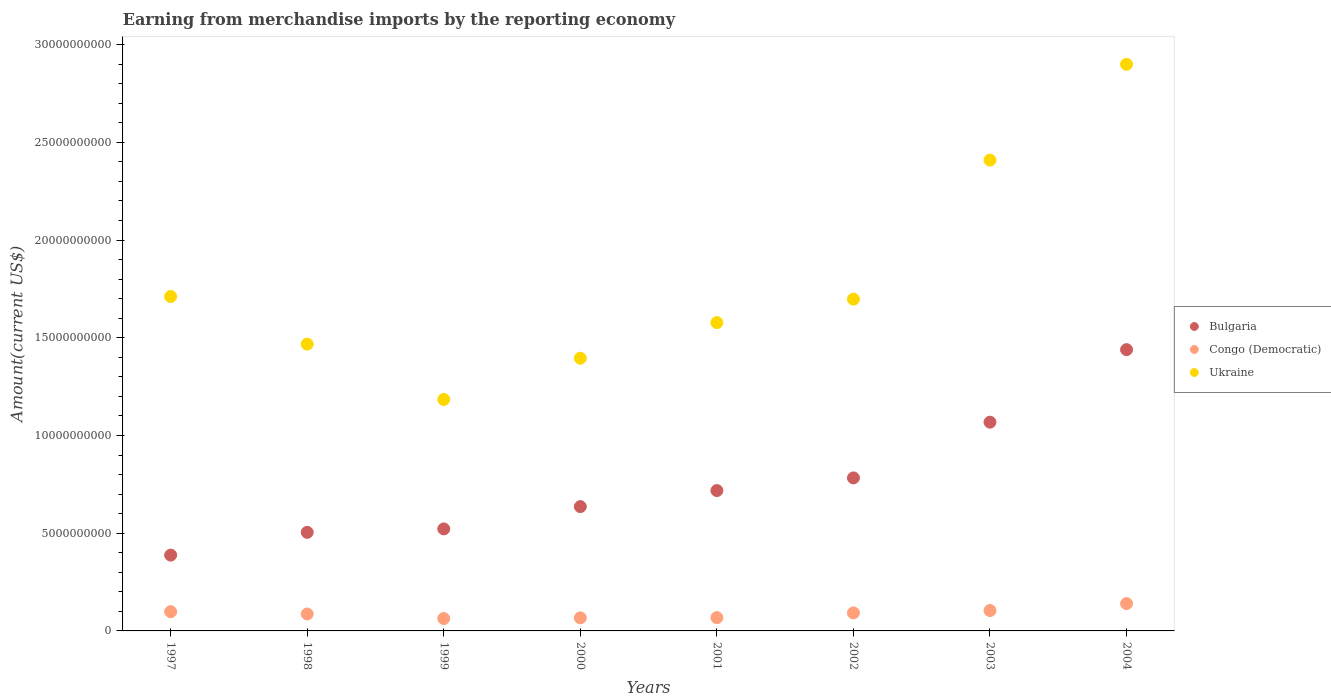Is the number of dotlines equal to the number of legend labels?
Your answer should be compact. Yes. What is the amount earned from merchandise imports in Bulgaria in 2003?
Offer a very short reply. 1.07e+1. Across all years, what is the maximum amount earned from merchandise imports in Bulgaria?
Ensure brevity in your answer.  1.44e+1. Across all years, what is the minimum amount earned from merchandise imports in Bulgaria?
Give a very brief answer. 3.88e+09. In which year was the amount earned from merchandise imports in Congo (Democratic) maximum?
Provide a short and direct response. 2004. In which year was the amount earned from merchandise imports in Bulgaria minimum?
Offer a terse response. 1997. What is the total amount earned from merchandise imports in Ukraine in the graph?
Provide a succinct answer. 1.43e+11. What is the difference between the amount earned from merchandise imports in Ukraine in 2002 and that in 2003?
Provide a short and direct response. -7.11e+09. What is the difference between the amount earned from merchandise imports in Ukraine in 1997 and the amount earned from merchandise imports in Congo (Democratic) in 2001?
Your response must be concise. 1.64e+1. What is the average amount earned from merchandise imports in Ukraine per year?
Your answer should be very brief. 1.79e+1. In the year 1997, what is the difference between the amount earned from merchandise imports in Bulgaria and amount earned from merchandise imports in Ukraine?
Your answer should be compact. -1.32e+1. In how many years, is the amount earned from merchandise imports in Congo (Democratic) greater than 7000000000 US$?
Provide a succinct answer. 0. What is the ratio of the amount earned from merchandise imports in Congo (Democratic) in 1998 to that in 1999?
Make the answer very short. 1.37. Is the difference between the amount earned from merchandise imports in Bulgaria in 2003 and 2004 greater than the difference between the amount earned from merchandise imports in Ukraine in 2003 and 2004?
Your answer should be very brief. Yes. What is the difference between the highest and the second highest amount earned from merchandise imports in Bulgaria?
Keep it short and to the point. 3.71e+09. What is the difference between the highest and the lowest amount earned from merchandise imports in Bulgaria?
Offer a very short reply. 1.05e+1. In how many years, is the amount earned from merchandise imports in Bulgaria greater than the average amount earned from merchandise imports in Bulgaria taken over all years?
Your response must be concise. 3. How many dotlines are there?
Keep it short and to the point. 3. How many years are there in the graph?
Give a very brief answer. 8. Are the values on the major ticks of Y-axis written in scientific E-notation?
Your response must be concise. No. Does the graph contain any zero values?
Keep it short and to the point. No. What is the title of the graph?
Your response must be concise. Earning from merchandise imports by the reporting economy. Does "Latin America(all income levels)" appear as one of the legend labels in the graph?
Provide a succinct answer. No. What is the label or title of the X-axis?
Your answer should be very brief. Years. What is the label or title of the Y-axis?
Your answer should be very brief. Amount(current US$). What is the Amount(current US$) in Bulgaria in 1997?
Provide a short and direct response. 3.88e+09. What is the Amount(current US$) in Congo (Democratic) in 1997?
Keep it short and to the point. 9.85e+08. What is the Amount(current US$) in Ukraine in 1997?
Your answer should be very brief. 1.71e+1. What is the Amount(current US$) of Bulgaria in 1998?
Make the answer very short. 5.04e+09. What is the Amount(current US$) in Congo (Democratic) in 1998?
Your answer should be compact. 8.67e+08. What is the Amount(current US$) of Ukraine in 1998?
Make the answer very short. 1.47e+1. What is the Amount(current US$) of Bulgaria in 1999?
Keep it short and to the point. 5.22e+09. What is the Amount(current US$) in Congo (Democratic) in 1999?
Your answer should be very brief. 6.35e+08. What is the Amount(current US$) of Ukraine in 1999?
Provide a short and direct response. 1.18e+1. What is the Amount(current US$) in Bulgaria in 2000?
Offer a very short reply. 6.36e+09. What is the Amount(current US$) in Congo (Democratic) in 2000?
Your response must be concise. 6.68e+08. What is the Amount(current US$) of Ukraine in 2000?
Your answer should be very brief. 1.40e+1. What is the Amount(current US$) of Bulgaria in 2001?
Offer a very short reply. 7.18e+09. What is the Amount(current US$) in Congo (Democratic) in 2001?
Ensure brevity in your answer.  6.80e+08. What is the Amount(current US$) in Ukraine in 2001?
Provide a short and direct response. 1.58e+1. What is the Amount(current US$) of Bulgaria in 2002?
Your response must be concise. 7.83e+09. What is the Amount(current US$) in Congo (Democratic) in 2002?
Your answer should be very brief. 9.22e+08. What is the Amount(current US$) in Ukraine in 2002?
Your response must be concise. 1.70e+1. What is the Amount(current US$) in Bulgaria in 2003?
Keep it short and to the point. 1.07e+1. What is the Amount(current US$) of Congo (Democratic) in 2003?
Your answer should be compact. 1.05e+09. What is the Amount(current US$) of Ukraine in 2003?
Ensure brevity in your answer.  2.41e+1. What is the Amount(current US$) in Bulgaria in 2004?
Offer a terse response. 1.44e+1. What is the Amount(current US$) in Congo (Democratic) in 2004?
Provide a short and direct response. 1.40e+09. What is the Amount(current US$) in Ukraine in 2004?
Give a very brief answer. 2.90e+1. Across all years, what is the maximum Amount(current US$) in Bulgaria?
Your answer should be compact. 1.44e+1. Across all years, what is the maximum Amount(current US$) in Congo (Democratic)?
Offer a terse response. 1.40e+09. Across all years, what is the maximum Amount(current US$) of Ukraine?
Offer a terse response. 2.90e+1. Across all years, what is the minimum Amount(current US$) in Bulgaria?
Ensure brevity in your answer.  3.88e+09. Across all years, what is the minimum Amount(current US$) in Congo (Democratic)?
Your answer should be very brief. 6.35e+08. Across all years, what is the minimum Amount(current US$) in Ukraine?
Ensure brevity in your answer.  1.18e+1. What is the total Amount(current US$) in Bulgaria in the graph?
Make the answer very short. 6.06e+1. What is the total Amount(current US$) in Congo (Democratic) in the graph?
Make the answer very short. 7.20e+09. What is the total Amount(current US$) of Ukraine in the graph?
Provide a short and direct response. 1.43e+11. What is the difference between the Amount(current US$) in Bulgaria in 1997 and that in 1998?
Keep it short and to the point. -1.16e+09. What is the difference between the Amount(current US$) of Congo (Democratic) in 1997 and that in 1998?
Your response must be concise. 1.18e+08. What is the difference between the Amount(current US$) in Ukraine in 1997 and that in 1998?
Provide a short and direct response. 2.44e+09. What is the difference between the Amount(current US$) of Bulgaria in 1997 and that in 1999?
Provide a succinct answer. -1.34e+09. What is the difference between the Amount(current US$) in Congo (Democratic) in 1997 and that in 1999?
Ensure brevity in your answer.  3.50e+08. What is the difference between the Amount(current US$) of Ukraine in 1997 and that in 1999?
Offer a terse response. 5.27e+09. What is the difference between the Amount(current US$) of Bulgaria in 1997 and that in 2000?
Offer a very short reply. -2.48e+09. What is the difference between the Amount(current US$) of Congo (Democratic) in 1997 and that in 2000?
Keep it short and to the point. 3.17e+08. What is the difference between the Amount(current US$) in Ukraine in 1997 and that in 2000?
Offer a very short reply. 3.16e+09. What is the difference between the Amount(current US$) of Bulgaria in 1997 and that in 2001?
Your response must be concise. -3.30e+09. What is the difference between the Amount(current US$) of Congo (Democratic) in 1997 and that in 2001?
Make the answer very short. 3.05e+08. What is the difference between the Amount(current US$) in Ukraine in 1997 and that in 2001?
Your answer should be very brief. 1.34e+09. What is the difference between the Amount(current US$) of Bulgaria in 1997 and that in 2002?
Offer a terse response. -3.95e+09. What is the difference between the Amount(current US$) of Congo (Democratic) in 1997 and that in 2002?
Your response must be concise. 6.32e+07. What is the difference between the Amount(current US$) in Ukraine in 1997 and that in 2002?
Your answer should be compact. 1.37e+08. What is the difference between the Amount(current US$) in Bulgaria in 1997 and that in 2003?
Give a very brief answer. -6.80e+09. What is the difference between the Amount(current US$) in Congo (Democratic) in 1997 and that in 2003?
Ensure brevity in your answer.  -6.04e+07. What is the difference between the Amount(current US$) of Ukraine in 1997 and that in 2003?
Your response must be concise. -6.98e+09. What is the difference between the Amount(current US$) of Bulgaria in 1997 and that in 2004?
Your answer should be compact. -1.05e+1. What is the difference between the Amount(current US$) of Congo (Democratic) in 1997 and that in 2004?
Give a very brief answer. -4.14e+08. What is the difference between the Amount(current US$) of Ukraine in 1997 and that in 2004?
Ensure brevity in your answer.  -1.19e+1. What is the difference between the Amount(current US$) in Bulgaria in 1998 and that in 1999?
Provide a succinct answer. -1.76e+08. What is the difference between the Amount(current US$) of Congo (Democratic) in 1998 and that in 1999?
Provide a succinct answer. 2.32e+08. What is the difference between the Amount(current US$) in Ukraine in 1998 and that in 1999?
Your answer should be very brief. 2.83e+09. What is the difference between the Amount(current US$) of Bulgaria in 1998 and that in 2000?
Your response must be concise. -1.32e+09. What is the difference between the Amount(current US$) of Congo (Democratic) in 1998 and that in 2000?
Ensure brevity in your answer.  1.98e+08. What is the difference between the Amount(current US$) of Ukraine in 1998 and that in 2000?
Keep it short and to the point. 7.21e+08. What is the difference between the Amount(current US$) of Bulgaria in 1998 and that in 2001?
Your response must be concise. -2.14e+09. What is the difference between the Amount(current US$) in Congo (Democratic) in 1998 and that in 2001?
Your answer should be compact. 1.86e+08. What is the difference between the Amount(current US$) in Ukraine in 1998 and that in 2001?
Your answer should be compact. -1.10e+09. What is the difference between the Amount(current US$) in Bulgaria in 1998 and that in 2002?
Keep it short and to the point. -2.79e+09. What is the difference between the Amount(current US$) of Congo (Democratic) in 1998 and that in 2002?
Your response must be concise. -5.51e+07. What is the difference between the Amount(current US$) of Ukraine in 1998 and that in 2002?
Provide a short and direct response. -2.30e+09. What is the difference between the Amount(current US$) of Bulgaria in 1998 and that in 2003?
Give a very brief answer. -5.64e+09. What is the difference between the Amount(current US$) of Congo (Democratic) in 1998 and that in 2003?
Keep it short and to the point. -1.79e+08. What is the difference between the Amount(current US$) of Ukraine in 1998 and that in 2003?
Your response must be concise. -9.42e+09. What is the difference between the Amount(current US$) in Bulgaria in 1998 and that in 2004?
Give a very brief answer. -9.35e+09. What is the difference between the Amount(current US$) of Congo (Democratic) in 1998 and that in 2004?
Your answer should be very brief. -5.33e+08. What is the difference between the Amount(current US$) of Ukraine in 1998 and that in 2004?
Your answer should be very brief. -1.43e+1. What is the difference between the Amount(current US$) in Bulgaria in 1999 and that in 2000?
Your answer should be very brief. -1.14e+09. What is the difference between the Amount(current US$) of Congo (Democratic) in 1999 and that in 2000?
Offer a very short reply. -3.35e+07. What is the difference between the Amount(current US$) of Ukraine in 1999 and that in 2000?
Ensure brevity in your answer.  -2.11e+09. What is the difference between the Amount(current US$) in Bulgaria in 1999 and that in 2001?
Keep it short and to the point. -1.96e+09. What is the difference between the Amount(current US$) of Congo (Democratic) in 1999 and that in 2001?
Offer a very short reply. -4.54e+07. What is the difference between the Amount(current US$) in Ukraine in 1999 and that in 2001?
Offer a terse response. -3.93e+09. What is the difference between the Amount(current US$) in Bulgaria in 1999 and that in 2002?
Your answer should be very brief. -2.61e+09. What is the difference between the Amount(current US$) of Congo (Democratic) in 1999 and that in 2002?
Offer a very short reply. -2.87e+08. What is the difference between the Amount(current US$) in Ukraine in 1999 and that in 2002?
Offer a terse response. -5.13e+09. What is the difference between the Amount(current US$) in Bulgaria in 1999 and that in 2003?
Your answer should be very brief. -5.46e+09. What is the difference between the Amount(current US$) of Congo (Democratic) in 1999 and that in 2003?
Ensure brevity in your answer.  -4.11e+08. What is the difference between the Amount(current US$) of Ukraine in 1999 and that in 2003?
Keep it short and to the point. -1.22e+1. What is the difference between the Amount(current US$) of Bulgaria in 1999 and that in 2004?
Give a very brief answer. -9.17e+09. What is the difference between the Amount(current US$) in Congo (Democratic) in 1999 and that in 2004?
Your response must be concise. -7.65e+08. What is the difference between the Amount(current US$) in Ukraine in 1999 and that in 2004?
Offer a terse response. -1.72e+1. What is the difference between the Amount(current US$) in Bulgaria in 2000 and that in 2001?
Your answer should be compact. -8.21e+08. What is the difference between the Amount(current US$) in Congo (Democratic) in 2000 and that in 2001?
Provide a succinct answer. -1.19e+07. What is the difference between the Amount(current US$) in Ukraine in 2000 and that in 2001?
Make the answer very short. -1.82e+09. What is the difference between the Amount(current US$) of Bulgaria in 2000 and that in 2002?
Provide a short and direct response. -1.47e+09. What is the difference between the Amount(current US$) in Congo (Democratic) in 2000 and that in 2002?
Offer a terse response. -2.53e+08. What is the difference between the Amount(current US$) in Ukraine in 2000 and that in 2002?
Your answer should be very brief. -3.02e+09. What is the difference between the Amount(current US$) in Bulgaria in 2000 and that in 2003?
Keep it short and to the point. -4.32e+09. What is the difference between the Amount(current US$) of Congo (Democratic) in 2000 and that in 2003?
Make the answer very short. -3.77e+08. What is the difference between the Amount(current US$) of Ukraine in 2000 and that in 2003?
Your answer should be compact. -1.01e+1. What is the difference between the Amount(current US$) in Bulgaria in 2000 and that in 2004?
Offer a very short reply. -8.03e+09. What is the difference between the Amount(current US$) of Congo (Democratic) in 2000 and that in 2004?
Give a very brief answer. -7.31e+08. What is the difference between the Amount(current US$) of Ukraine in 2000 and that in 2004?
Your answer should be compact. -1.50e+1. What is the difference between the Amount(current US$) of Bulgaria in 2001 and that in 2002?
Offer a terse response. -6.48e+08. What is the difference between the Amount(current US$) of Congo (Democratic) in 2001 and that in 2002?
Keep it short and to the point. -2.42e+08. What is the difference between the Amount(current US$) of Ukraine in 2001 and that in 2002?
Give a very brief answer. -1.20e+09. What is the difference between the Amount(current US$) of Bulgaria in 2001 and that in 2003?
Offer a very short reply. -3.50e+09. What is the difference between the Amount(current US$) in Congo (Democratic) in 2001 and that in 2003?
Give a very brief answer. -3.65e+08. What is the difference between the Amount(current US$) in Ukraine in 2001 and that in 2003?
Your answer should be very brief. -8.31e+09. What is the difference between the Amount(current US$) in Bulgaria in 2001 and that in 2004?
Your response must be concise. -7.21e+09. What is the difference between the Amount(current US$) in Congo (Democratic) in 2001 and that in 2004?
Offer a terse response. -7.19e+08. What is the difference between the Amount(current US$) of Ukraine in 2001 and that in 2004?
Your answer should be very brief. -1.32e+1. What is the difference between the Amount(current US$) of Bulgaria in 2002 and that in 2003?
Offer a very short reply. -2.85e+09. What is the difference between the Amount(current US$) of Congo (Democratic) in 2002 and that in 2003?
Your answer should be compact. -1.24e+08. What is the difference between the Amount(current US$) in Ukraine in 2002 and that in 2003?
Provide a succinct answer. -7.11e+09. What is the difference between the Amount(current US$) in Bulgaria in 2002 and that in 2004?
Make the answer very short. -6.56e+09. What is the difference between the Amount(current US$) of Congo (Democratic) in 2002 and that in 2004?
Make the answer very short. -4.78e+08. What is the difference between the Amount(current US$) of Ukraine in 2002 and that in 2004?
Give a very brief answer. -1.20e+1. What is the difference between the Amount(current US$) in Bulgaria in 2003 and that in 2004?
Offer a very short reply. -3.71e+09. What is the difference between the Amount(current US$) of Congo (Democratic) in 2003 and that in 2004?
Provide a succinct answer. -3.54e+08. What is the difference between the Amount(current US$) of Ukraine in 2003 and that in 2004?
Give a very brief answer. -4.90e+09. What is the difference between the Amount(current US$) in Bulgaria in 1997 and the Amount(current US$) in Congo (Democratic) in 1998?
Your answer should be compact. 3.01e+09. What is the difference between the Amount(current US$) in Bulgaria in 1997 and the Amount(current US$) in Ukraine in 1998?
Provide a short and direct response. -1.08e+1. What is the difference between the Amount(current US$) of Congo (Democratic) in 1997 and the Amount(current US$) of Ukraine in 1998?
Offer a very short reply. -1.37e+1. What is the difference between the Amount(current US$) of Bulgaria in 1997 and the Amount(current US$) of Congo (Democratic) in 1999?
Provide a succinct answer. 3.24e+09. What is the difference between the Amount(current US$) in Bulgaria in 1997 and the Amount(current US$) in Ukraine in 1999?
Give a very brief answer. -7.96e+09. What is the difference between the Amount(current US$) of Congo (Democratic) in 1997 and the Amount(current US$) of Ukraine in 1999?
Provide a succinct answer. -1.09e+1. What is the difference between the Amount(current US$) in Bulgaria in 1997 and the Amount(current US$) in Congo (Democratic) in 2000?
Ensure brevity in your answer.  3.21e+09. What is the difference between the Amount(current US$) in Bulgaria in 1997 and the Amount(current US$) in Ukraine in 2000?
Ensure brevity in your answer.  -1.01e+1. What is the difference between the Amount(current US$) of Congo (Democratic) in 1997 and the Amount(current US$) of Ukraine in 2000?
Keep it short and to the point. -1.30e+1. What is the difference between the Amount(current US$) in Bulgaria in 1997 and the Amount(current US$) in Congo (Democratic) in 2001?
Your answer should be compact. 3.20e+09. What is the difference between the Amount(current US$) in Bulgaria in 1997 and the Amount(current US$) in Ukraine in 2001?
Ensure brevity in your answer.  -1.19e+1. What is the difference between the Amount(current US$) in Congo (Democratic) in 1997 and the Amount(current US$) in Ukraine in 2001?
Offer a very short reply. -1.48e+1. What is the difference between the Amount(current US$) of Bulgaria in 1997 and the Amount(current US$) of Congo (Democratic) in 2002?
Give a very brief answer. 2.96e+09. What is the difference between the Amount(current US$) in Bulgaria in 1997 and the Amount(current US$) in Ukraine in 2002?
Give a very brief answer. -1.31e+1. What is the difference between the Amount(current US$) in Congo (Democratic) in 1997 and the Amount(current US$) in Ukraine in 2002?
Ensure brevity in your answer.  -1.60e+1. What is the difference between the Amount(current US$) in Bulgaria in 1997 and the Amount(current US$) in Congo (Democratic) in 2003?
Provide a short and direct response. 2.83e+09. What is the difference between the Amount(current US$) of Bulgaria in 1997 and the Amount(current US$) of Ukraine in 2003?
Your answer should be compact. -2.02e+1. What is the difference between the Amount(current US$) in Congo (Democratic) in 1997 and the Amount(current US$) in Ukraine in 2003?
Your answer should be compact. -2.31e+1. What is the difference between the Amount(current US$) in Bulgaria in 1997 and the Amount(current US$) in Congo (Democratic) in 2004?
Provide a succinct answer. 2.48e+09. What is the difference between the Amount(current US$) of Bulgaria in 1997 and the Amount(current US$) of Ukraine in 2004?
Offer a very short reply. -2.51e+1. What is the difference between the Amount(current US$) of Congo (Democratic) in 1997 and the Amount(current US$) of Ukraine in 2004?
Give a very brief answer. -2.80e+1. What is the difference between the Amount(current US$) of Bulgaria in 1998 and the Amount(current US$) of Congo (Democratic) in 1999?
Give a very brief answer. 4.41e+09. What is the difference between the Amount(current US$) of Bulgaria in 1998 and the Amount(current US$) of Ukraine in 1999?
Provide a succinct answer. -6.80e+09. What is the difference between the Amount(current US$) of Congo (Democratic) in 1998 and the Amount(current US$) of Ukraine in 1999?
Your answer should be very brief. -1.10e+1. What is the difference between the Amount(current US$) of Bulgaria in 1998 and the Amount(current US$) of Congo (Democratic) in 2000?
Ensure brevity in your answer.  4.38e+09. What is the difference between the Amount(current US$) of Bulgaria in 1998 and the Amount(current US$) of Ukraine in 2000?
Keep it short and to the point. -8.91e+09. What is the difference between the Amount(current US$) in Congo (Democratic) in 1998 and the Amount(current US$) in Ukraine in 2000?
Give a very brief answer. -1.31e+1. What is the difference between the Amount(current US$) of Bulgaria in 1998 and the Amount(current US$) of Congo (Democratic) in 2001?
Keep it short and to the point. 4.36e+09. What is the difference between the Amount(current US$) of Bulgaria in 1998 and the Amount(current US$) of Ukraine in 2001?
Your answer should be compact. -1.07e+1. What is the difference between the Amount(current US$) in Congo (Democratic) in 1998 and the Amount(current US$) in Ukraine in 2001?
Provide a succinct answer. -1.49e+1. What is the difference between the Amount(current US$) in Bulgaria in 1998 and the Amount(current US$) in Congo (Democratic) in 2002?
Keep it short and to the point. 4.12e+09. What is the difference between the Amount(current US$) in Bulgaria in 1998 and the Amount(current US$) in Ukraine in 2002?
Keep it short and to the point. -1.19e+1. What is the difference between the Amount(current US$) of Congo (Democratic) in 1998 and the Amount(current US$) of Ukraine in 2002?
Offer a very short reply. -1.61e+1. What is the difference between the Amount(current US$) in Bulgaria in 1998 and the Amount(current US$) in Congo (Democratic) in 2003?
Your response must be concise. 4.00e+09. What is the difference between the Amount(current US$) of Bulgaria in 1998 and the Amount(current US$) of Ukraine in 2003?
Offer a very short reply. -1.90e+1. What is the difference between the Amount(current US$) in Congo (Democratic) in 1998 and the Amount(current US$) in Ukraine in 2003?
Keep it short and to the point. -2.32e+1. What is the difference between the Amount(current US$) of Bulgaria in 1998 and the Amount(current US$) of Congo (Democratic) in 2004?
Your answer should be compact. 3.65e+09. What is the difference between the Amount(current US$) of Bulgaria in 1998 and the Amount(current US$) of Ukraine in 2004?
Offer a very short reply. -2.40e+1. What is the difference between the Amount(current US$) of Congo (Democratic) in 1998 and the Amount(current US$) of Ukraine in 2004?
Your answer should be compact. -2.81e+1. What is the difference between the Amount(current US$) in Bulgaria in 1999 and the Amount(current US$) in Congo (Democratic) in 2000?
Provide a succinct answer. 4.55e+09. What is the difference between the Amount(current US$) in Bulgaria in 1999 and the Amount(current US$) in Ukraine in 2000?
Your response must be concise. -8.73e+09. What is the difference between the Amount(current US$) of Congo (Democratic) in 1999 and the Amount(current US$) of Ukraine in 2000?
Give a very brief answer. -1.33e+1. What is the difference between the Amount(current US$) in Bulgaria in 1999 and the Amount(current US$) in Congo (Democratic) in 2001?
Offer a very short reply. 4.54e+09. What is the difference between the Amount(current US$) of Bulgaria in 1999 and the Amount(current US$) of Ukraine in 2001?
Your response must be concise. -1.06e+1. What is the difference between the Amount(current US$) in Congo (Democratic) in 1999 and the Amount(current US$) in Ukraine in 2001?
Your answer should be very brief. -1.51e+1. What is the difference between the Amount(current US$) of Bulgaria in 1999 and the Amount(current US$) of Congo (Democratic) in 2002?
Provide a succinct answer. 4.30e+09. What is the difference between the Amount(current US$) of Bulgaria in 1999 and the Amount(current US$) of Ukraine in 2002?
Give a very brief answer. -1.18e+1. What is the difference between the Amount(current US$) in Congo (Democratic) in 1999 and the Amount(current US$) in Ukraine in 2002?
Provide a succinct answer. -1.63e+1. What is the difference between the Amount(current US$) of Bulgaria in 1999 and the Amount(current US$) of Congo (Democratic) in 2003?
Offer a terse response. 4.17e+09. What is the difference between the Amount(current US$) in Bulgaria in 1999 and the Amount(current US$) in Ukraine in 2003?
Provide a succinct answer. -1.89e+1. What is the difference between the Amount(current US$) in Congo (Democratic) in 1999 and the Amount(current US$) in Ukraine in 2003?
Your response must be concise. -2.35e+1. What is the difference between the Amount(current US$) in Bulgaria in 1999 and the Amount(current US$) in Congo (Democratic) in 2004?
Your response must be concise. 3.82e+09. What is the difference between the Amount(current US$) in Bulgaria in 1999 and the Amount(current US$) in Ukraine in 2004?
Your response must be concise. -2.38e+1. What is the difference between the Amount(current US$) of Congo (Democratic) in 1999 and the Amount(current US$) of Ukraine in 2004?
Make the answer very short. -2.84e+1. What is the difference between the Amount(current US$) of Bulgaria in 2000 and the Amount(current US$) of Congo (Democratic) in 2001?
Offer a terse response. 5.68e+09. What is the difference between the Amount(current US$) in Bulgaria in 2000 and the Amount(current US$) in Ukraine in 2001?
Offer a terse response. -9.42e+09. What is the difference between the Amount(current US$) in Congo (Democratic) in 2000 and the Amount(current US$) in Ukraine in 2001?
Offer a terse response. -1.51e+1. What is the difference between the Amount(current US$) in Bulgaria in 2000 and the Amount(current US$) in Congo (Democratic) in 2002?
Your response must be concise. 5.44e+09. What is the difference between the Amount(current US$) in Bulgaria in 2000 and the Amount(current US$) in Ukraine in 2002?
Provide a succinct answer. -1.06e+1. What is the difference between the Amount(current US$) in Congo (Democratic) in 2000 and the Amount(current US$) in Ukraine in 2002?
Ensure brevity in your answer.  -1.63e+1. What is the difference between the Amount(current US$) in Bulgaria in 2000 and the Amount(current US$) in Congo (Democratic) in 2003?
Keep it short and to the point. 5.32e+09. What is the difference between the Amount(current US$) in Bulgaria in 2000 and the Amount(current US$) in Ukraine in 2003?
Offer a terse response. -1.77e+1. What is the difference between the Amount(current US$) in Congo (Democratic) in 2000 and the Amount(current US$) in Ukraine in 2003?
Provide a succinct answer. -2.34e+1. What is the difference between the Amount(current US$) in Bulgaria in 2000 and the Amount(current US$) in Congo (Democratic) in 2004?
Provide a short and direct response. 4.96e+09. What is the difference between the Amount(current US$) of Bulgaria in 2000 and the Amount(current US$) of Ukraine in 2004?
Your answer should be compact. -2.26e+1. What is the difference between the Amount(current US$) of Congo (Democratic) in 2000 and the Amount(current US$) of Ukraine in 2004?
Provide a succinct answer. -2.83e+1. What is the difference between the Amount(current US$) in Bulgaria in 2001 and the Amount(current US$) in Congo (Democratic) in 2002?
Your answer should be very brief. 6.26e+09. What is the difference between the Amount(current US$) of Bulgaria in 2001 and the Amount(current US$) of Ukraine in 2002?
Provide a short and direct response. -9.79e+09. What is the difference between the Amount(current US$) in Congo (Democratic) in 2001 and the Amount(current US$) in Ukraine in 2002?
Keep it short and to the point. -1.63e+1. What is the difference between the Amount(current US$) of Bulgaria in 2001 and the Amount(current US$) of Congo (Democratic) in 2003?
Provide a succinct answer. 6.14e+09. What is the difference between the Amount(current US$) of Bulgaria in 2001 and the Amount(current US$) of Ukraine in 2003?
Your answer should be compact. -1.69e+1. What is the difference between the Amount(current US$) in Congo (Democratic) in 2001 and the Amount(current US$) in Ukraine in 2003?
Your answer should be compact. -2.34e+1. What is the difference between the Amount(current US$) in Bulgaria in 2001 and the Amount(current US$) in Congo (Democratic) in 2004?
Offer a very short reply. 5.78e+09. What is the difference between the Amount(current US$) of Bulgaria in 2001 and the Amount(current US$) of Ukraine in 2004?
Make the answer very short. -2.18e+1. What is the difference between the Amount(current US$) of Congo (Democratic) in 2001 and the Amount(current US$) of Ukraine in 2004?
Provide a short and direct response. -2.83e+1. What is the difference between the Amount(current US$) in Bulgaria in 2002 and the Amount(current US$) in Congo (Democratic) in 2003?
Give a very brief answer. 6.79e+09. What is the difference between the Amount(current US$) in Bulgaria in 2002 and the Amount(current US$) in Ukraine in 2003?
Ensure brevity in your answer.  -1.63e+1. What is the difference between the Amount(current US$) of Congo (Democratic) in 2002 and the Amount(current US$) of Ukraine in 2003?
Your answer should be very brief. -2.32e+1. What is the difference between the Amount(current US$) in Bulgaria in 2002 and the Amount(current US$) in Congo (Democratic) in 2004?
Provide a succinct answer. 6.43e+09. What is the difference between the Amount(current US$) of Bulgaria in 2002 and the Amount(current US$) of Ukraine in 2004?
Keep it short and to the point. -2.12e+1. What is the difference between the Amount(current US$) of Congo (Democratic) in 2002 and the Amount(current US$) of Ukraine in 2004?
Offer a terse response. -2.81e+1. What is the difference between the Amount(current US$) in Bulgaria in 2003 and the Amount(current US$) in Congo (Democratic) in 2004?
Make the answer very short. 9.28e+09. What is the difference between the Amount(current US$) of Bulgaria in 2003 and the Amount(current US$) of Ukraine in 2004?
Your response must be concise. -1.83e+1. What is the difference between the Amount(current US$) of Congo (Democratic) in 2003 and the Amount(current US$) of Ukraine in 2004?
Your answer should be compact. -2.80e+1. What is the average Amount(current US$) in Bulgaria per year?
Your answer should be compact. 7.57e+09. What is the average Amount(current US$) in Congo (Democratic) per year?
Offer a very short reply. 9.00e+08. What is the average Amount(current US$) in Ukraine per year?
Your response must be concise. 1.79e+1. In the year 1997, what is the difference between the Amount(current US$) of Bulgaria and Amount(current US$) of Congo (Democratic)?
Keep it short and to the point. 2.89e+09. In the year 1997, what is the difference between the Amount(current US$) of Bulgaria and Amount(current US$) of Ukraine?
Your answer should be compact. -1.32e+1. In the year 1997, what is the difference between the Amount(current US$) of Congo (Democratic) and Amount(current US$) of Ukraine?
Ensure brevity in your answer.  -1.61e+1. In the year 1998, what is the difference between the Amount(current US$) of Bulgaria and Amount(current US$) of Congo (Democratic)?
Provide a succinct answer. 4.18e+09. In the year 1998, what is the difference between the Amount(current US$) of Bulgaria and Amount(current US$) of Ukraine?
Provide a short and direct response. -9.63e+09. In the year 1998, what is the difference between the Amount(current US$) in Congo (Democratic) and Amount(current US$) in Ukraine?
Ensure brevity in your answer.  -1.38e+1. In the year 1999, what is the difference between the Amount(current US$) of Bulgaria and Amount(current US$) of Congo (Democratic)?
Ensure brevity in your answer.  4.59e+09. In the year 1999, what is the difference between the Amount(current US$) in Bulgaria and Amount(current US$) in Ukraine?
Your answer should be very brief. -6.62e+09. In the year 1999, what is the difference between the Amount(current US$) in Congo (Democratic) and Amount(current US$) in Ukraine?
Provide a short and direct response. -1.12e+1. In the year 2000, what is the difference between the Amount(current US$) of Bulgaria and Amount(current US$) of Congo (Democratic)?
Ensure brevity in your answer.  5.69e+09. In the year 2000, what is the difference between the Amount(current US$) in Bulgaria and Amount(current US$) in Ukraine?
Ensure brevity in your answer.  -7.59e+09. In the year 2000, what is the difference between the Amount(current US$) of Congo (Democratic) and Amount(current US$) of Ukraine?
Ensure brevity in your answer.  -1.33e+1. In the year 2001, what is the difference between the Amount(current US$) of Bulgaria and Amount(current US$) of Congo (Democratic)?
Ensure brevity in your answer.  6.50e+09. In the year 2001, what is the difference between the Amount(current US$) in Bulgaria and Amount(current US$) in Ukraine?
Your answer should be very brief. -8.59e+09. In the year 2001, what is the difference between the Amount(current US$) in Congo (Democratic) and Amount(current US$) in Ukraine?
Your response must be concise. -1.51e+1. In the year 2002, what is the difference between the Amount(current US$) in Bulgaria and Amount(current US$) in Congo (Democratic)?
Offer a very short reply. 6.91e+09. In the year 2002, what is the difference between the Amount(current US$) in Bulgaria and Amount(current US$) in Ukraine?
Provide a succinct answer. -9.15e+09. In the year 2002, what is the difference between the Amount(current US$) of Congo (Democratic) and Amount(current US$) of Ukraine?
Offer a very short reply. -1.61e+1. In the year 2003, what is the difference between the Amount(current US$) of Bulgaria and Amount(current US$) of Congo (Democratic)?
Your answer should be very brief. 9.64e+09. In the year 2003, what is the difference between the Amount(current US$) in Bulgaria and Amount(current US$) in Ukraine?
Keep it short and to the point. -1.34e+1. In the year 2003, what is the difference between the Amount(current US$) of Congo (Democratic) and Amount(current US$) of Ukraine?
Give a very brief answer. -2.30e+1. In the year 2004, what is the difference between the Amount(current US$) of Bulgaria and Amount(current US$) of Congo (Democratic)?
Offer a terse response. 1.30e+1. In the year 2004, what is the difference between the Amount(current US$) in Bulgaria and Amount(current US$) in Ukraine?
Provide a short and direct response. -1.46e+1. In the year 2004, what is the difference between the Amount(current US$) in Congo (Democratic) and Amount(current US$) in Ukraine?
Give a very brief answer. -2.76e+1. What is the ratio of the Amount(current US$) of Bulgaria in 1997 to that in 1998?
Your response must be concise. 0.77. What is the ratio of the Amount(current US$) of Congo (Democratic) in 1997 to that in 1998?
Make the answer very short. 1.14. What is the ratio of the Amount(current US$) of Ukraine in 1997 to that in 1998?
Give a very brief answer. 1.17. What is the ratio of the Amount(current US$) of Bulgaria in 1997 to that in 1999?
Keep it short and to the point. 0.74. What is the ratio of the Amount(current US$) in Congo (Democratic) in 1997 to that in 1999?
Keep it short and to the point. 1.55. What is the ratio of the Amount(current US$) in Ukraine in 1997 to that in 1999?
Provide a succinct answer. 1.44. What is the ratio of the Amount(current US$) in Bulgaria in 1997 to that in 2000?
Provide a short and direct response. 0.61. What is the ratio of the Amount(current US$) in Congo (Democratic) in 1997 to that in 2000?
Your answer should be compact. 1.47. What is the ratio of the Amount(current US$) in Ukraine in 1997 to that in 2000?
Your answer should be compact. 1.23. What is the ratio of the Amount(current US$) in Bulgaria in 1997 to that in 2001?
Provide a succinct answer. 0.54. What is the ratio of the Amount(current US$) in Congo (Democratic) in 1997 to that in 2001?
Your answer should be compact. 1.45. What is the ratio of the Amount(current US$) in Ukraine in 1997 to that in 2001?
Offer a terse response. 1.08. What is the ratio of the Amount(current US$) of Bulgaria in 1997 to that in 2002?
Your answer should be very brief. 0.5. What is the ratio of the Amount(current US$) of Congo (Democratic) in 1997 to that in 2002?
Give a very brief answer. 1.07. What is the ratio of the Amount(current US$) of Ukraine in 1997 to that in 2002?
Give a very brief answer. 1.01. What is the ratio of the Amount(current US$) of Bulgaria in 1997 to that in 2003?
Provide a short and direct response. 0.36. What is the ratio of the Amount(current US$) in Congo (Democratic) in 1997 to that in 2003?
Ensure brevity in your answer.  0.94. What is the ratio of the Amount(current US$) in Ukraine in 1997 to that in 2003?
Your answer should be compact. 0.71. What is the ratio of the Amount(current US$) of Bulgaria in 1997 to that in 2004?
Ensure brevity in your answer.  0.27. What is the ratio of the Amount(current US$) in Congo (Democratic) in 1997 to that in 2004?
Provide a succinct answer. 0.7. What is the ratio of the Amount(current US$) in Ukraine in 1997 to that in 2004?
Your response must be concise. 0.59. What is the ratio of the Amount(current US$) in Bulgaria in 1998 to that in 1999?
Make the answer very short. 0.97. What is the ratio of the Amount(current US$) of Congo (Democratic) in 1998 to that in 1999?
Make the answer very short. 1.37. What is the ratio of the Amount(current US$) of Ukraine in 1998 to that in 1999?
Provide a short and direct response. 1.24. What is the ratio of the Amount(current US$) in Bulgaria in 1998 to that in 2000?
Your response must be concise. 0.79. What is the ratio of the Amount(current US$) of Congo (Democratic) in 1998 to that in 2000?
Provide a short and direct response. 1.3. What is the ratio of the Amount(current US$) in Ukraine in 1998 to that in 2000?
Your response must be concise. 1.05. What is the ratio of the Amount(current US$) of Bulgaria in 1998 to that in 2001?
Provide a succinct answer. 0.7. What is the ratio of the Amount(current US$) in Congo (Democratic) in 1998 to that in 2001?
Ensure brevity in your answer.  1.27. What is the ratio of the Amount(current US$) of Ukraine in 1998 to that in 2001?
Ensure brevity in your answer.  0.93. What is the ratio of the Amount(current US$) of Bulgaria in 1998 to that in 2002?
Give a very brief answer. 0.64. What is the ratio of the Amount(current US$) of Congo (Democratic) in 1998 to that in 2002?
Your response must be concise. 0.94. What is the ratio of the Amount(current US$) of Ukraine in 1998 to that in 2002?
Make the answer very short. 0.86. What is the ratio of the Amount(current US$) of Bulgaria in 1998 to that in 2003?
Provide a short and direct response. 0.47. What is the ratio of the Amount(current US$) in Congo (Democratic) in 1998 to that in 2003?
Offer a very short reply. 0.83. What is the ratio of the Amount(current US$) in Ukraine in 1998 to that in 2003?
Your answer should be compact. 0.61. What is the ratio of the Amount(current US$) of Bulgaria in 1998 to that in 2004?
Your answer should be compact. 0.35. What is the ratio of the Amount(current US$) in Congo (Democratic) in 1998 to that in 2004?
Provide a short and direct response. 0.62. What is the ratio of the Amount(current US$) in Ukraine in 1998 to that in 2004?
Offer a terse response. 0.51. What is the ratio of the Amount(current US$) of Bulgaria in 1999 to that in 2000?
Provide a short and direct response. 0.82. What is the ratio of the Amount(current US$) in Congo (Democratic) in 1999 to that in 2000?
Your answer should be very brief. 0.95. What is the ratio of the Amount(current US$) of Ukraine in 1999 to that in 2000?
Offer a terse response. 0.85. What is the ratio of the Amount(current US$) of Bulgaria in 1999 to that in 2001?
Give a very brief answer. 0.73. What is the ratio of the Amount(current US$) of Congo (Democratic) in 1999 to that in 2001?
Offer a terse response. 0.93. What is the ratio of the Amount(current US$) of Ukraine in 1999 to that in 2001?
Provide a succinct answer. 0.75. What is the ratio of the Amount(current US$) of Bulgaria in 1999 to that in 2002?
Your answer should be very brief. 0.67. What is the ratio of the Amount(current US$) of Congo (Democratic) in 1999 to that in 2002?
Your answer should be compact. 0.69. What is the ratio of the Amount(current US$) of Ukraine in 1999 to that in 2002?
Keep it short and to the point. 0.7. What is the ratio of the Amount(current US$) in Bulgaria in 1999 to that in 2003?
Offer a terse response. 0.49. What is the ratio of the Amount(current US$) in Congo (Democratic) in 1999 to that in 2003?
Provide a succinct answer. 0.61. What is the ratio of the Amount(current US$) of Ukraine in 1999 to that in 2003?
Offer a very short reply. 0.49. What is the ratio of the Amount(current US$) in Bulgaria in 1999 to that in 2004?
Keep it short and to the point. 0.36. What is the ratio of the Amount(current US$) in Congo (Democratic) in 1999 to that in 2004?
Your answer should be compact. 0.45. What is the ratio of the Amount(current US$) in Ukraine in 1999 to that in 2004?
Provide a succinct answer. 0.41. What is the ratio of the Amount(current US$) in Bulgaria in 2000 to that in 2001?
Offer a terse response. 0.89. What is the ratio of the Amount(current US$) in Congo (Democratic) in 2000 to that in 2001?
Your response must be concise. 0.98. What is the ratio of the Amount(current US$) of Ukraine in 2000 to that in 2001?
Offer a very short reply. 0.88. What is the ratio of the Amount(current US$) of Bulgaria in 2000 to that in 2002?
Your response must be concise. 0.81. What is the ratio of the Amount(current US$) in Congo (Democratic) in 2000 to that in 2002?
Make the answer very short. 0.72. What is the ratio of the Amount(current US$) of Ukraine in 2000 to that in 2002?
Your response must be concise. 0.82. What is the ratio of the Amount(current US$) of Bulgaria in 2000 to that in 2003?
Provide a short and direct response. 0.6. What is the ratio of the Amount(current US$) of Congo (Democratic) in 2000 to that in 2003?
Keep it short and to the point. 0.64. What is the ratio of the Amount(current US$) of Ukraine in 2000 to that in 2003?
Your answer should be very brief. 0.58. What is the ratio of the Amount(current US$) in Bulgaria in 2000 to that in 2004?
Ensure brevity in your answer.  0.44. What is the ratio of the Amount(current US$) in Congo (Democratic) in 2000 to that in 2004?
Your response must be concise. 0.48. What is the ratio of the Amount(current US$) of Ukraine in 2000 to that in 2004?
Make the answer very short. 0.48. What is the ratio of the Amount(current US$) of Bulgaria in 2001 to that in 2002?
Provide a succinct answer. 0.92. What is the ratio of the Amount(current US$) of Congo (Democratic) in 2001 to that in 2002?
Ensure brevity in your answer.  0.74. What is the ratio of the Amount(current US$) of Ukraine in 2001 to that in 2002?
Keep it short and to the point. 0.93. What is the ratio of the Amount(current US$) of Bulgaria in 2001 to that in 2003?
Keep it short and to the point. 0.67. What is the ratio of the Amount(current US$) in Congo (Democratic) in 2001 to that in 2003?
Keep it short and to the point. 0.65. What is the ratio of the Amount(current US$) in Ukraine in 2001 to that in 2003?
Give a very brief answer. 0.65. What is the ratio of the Amount(current US$) in Bulgaria in 2001 to that in 2004?
Your response must be concise. 0.5. What is the ratio of the Amount(current US$) in Congo (Democratic) in 2001 to that in 2004?
Provide a short and direct response. 0.49. What is the ratio of the Amount(current US$) in Ukraine in 2001 to that in 2004?
Offer a terse response. 0.54. What is the ratio of the Amount(current US$) in Bulgaria in 2002 to that in 2003?
Provide a succinct answer. 0.73. What is the ratio of the Amount(current US$) of Congo (Democratic) in 2002 to that in 2003?
Make the answer very short. 0.88. What is the ratio of the Amount(current US$) in Ukraine in 2002 to that in 2003?
Your response must be concise. 0.7. What is the ratio of the Amount(current US$) of Bulgaria in 2002 to that in 2004?
Your answer should be compact. 0.54. What is the ratio of the Amount(current US$) in Congo (Democratic) in 2002 to that in 2004?
Give a very brief answer. 0.66. What is the ratio of the Amount(current US$) in Ukraine in 2002 to that in 2004?
Offer a terse response. 0.59. What is the ratio of the Amount(current US$) in Bulgaria in 2003 to that in 2004?
Your answer should be very brief. 0.74. What is the ratio of the Amount(current US$) in Congo (Democratic) in 2003 to that in 2004?
Ensure brevity in your answer.  0.75. What is the ratio of the Amount(current US$) in Ukraine in 2003 to that in 2004?
Offer a very short reply. 0.83. What is the difference between the highest and the second highest Amount(current US$) in Bulgaria?
Provide a succinct answer. 3.71e+09. What is the difference between the highest and the second highest Amount(current US$) in Congo (Democratic)?
Your response must be concise. 3.54e+08. What is the difference between the highest and the second highest Amount(current US$) of Ukraine?
Your answer should be compact. 4.90e+09. What is the difference between the highest and the lowest Amount(current US$) in Bulgaria?
Make the answer very short. 1.05e+1. What is the difference between the highest and the lowest Amount(current US$) of Congo (Democratic)?
Make the answer very short. 7.65e+08. What is the difference between the highest and the lowest Amount(current US$) in Ukraine?
Your response must be concise. 1.72e+1. 